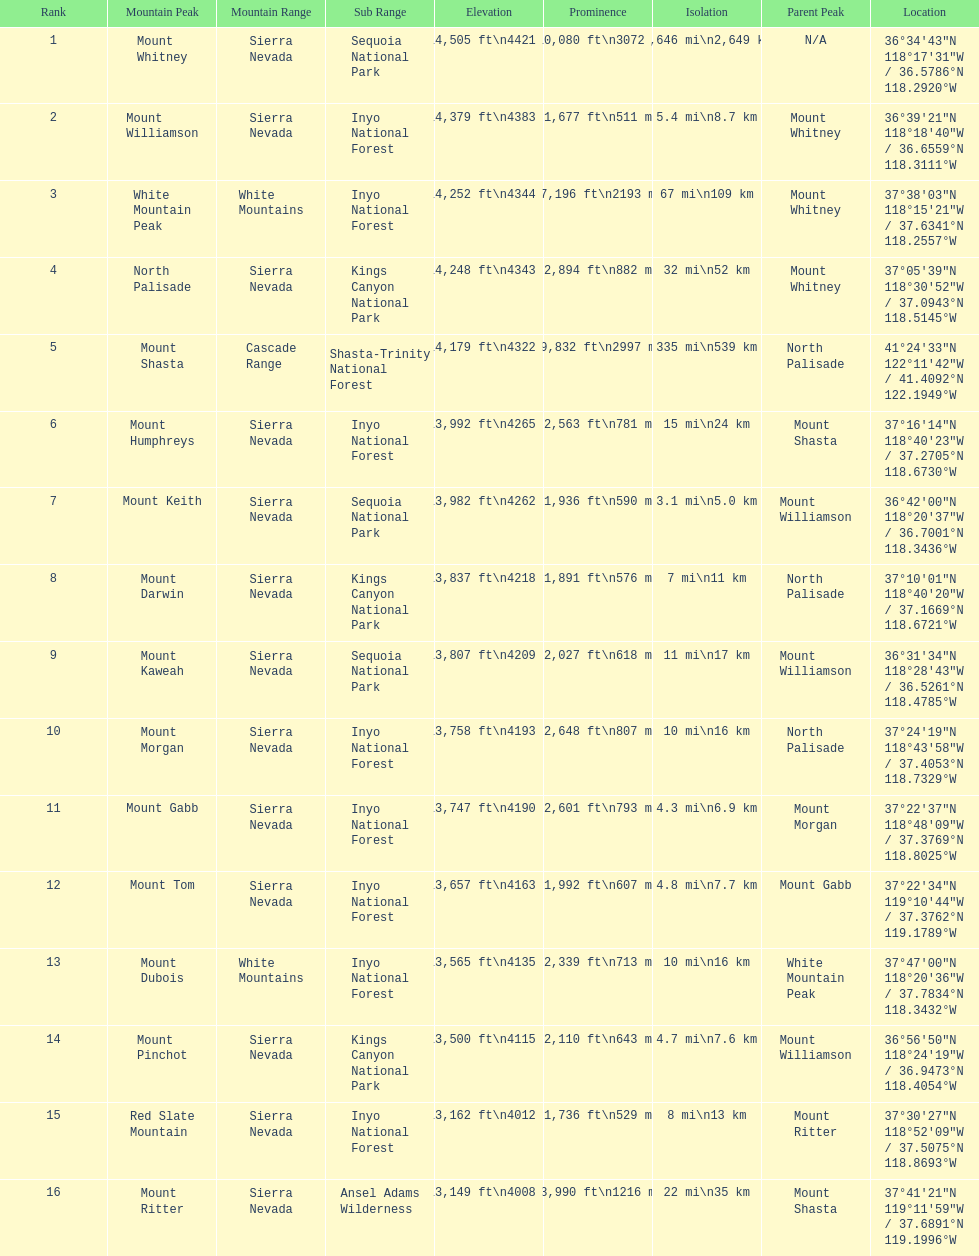Which mountain peak is the only mountain peak in the cascade range? Mount Shasta. 